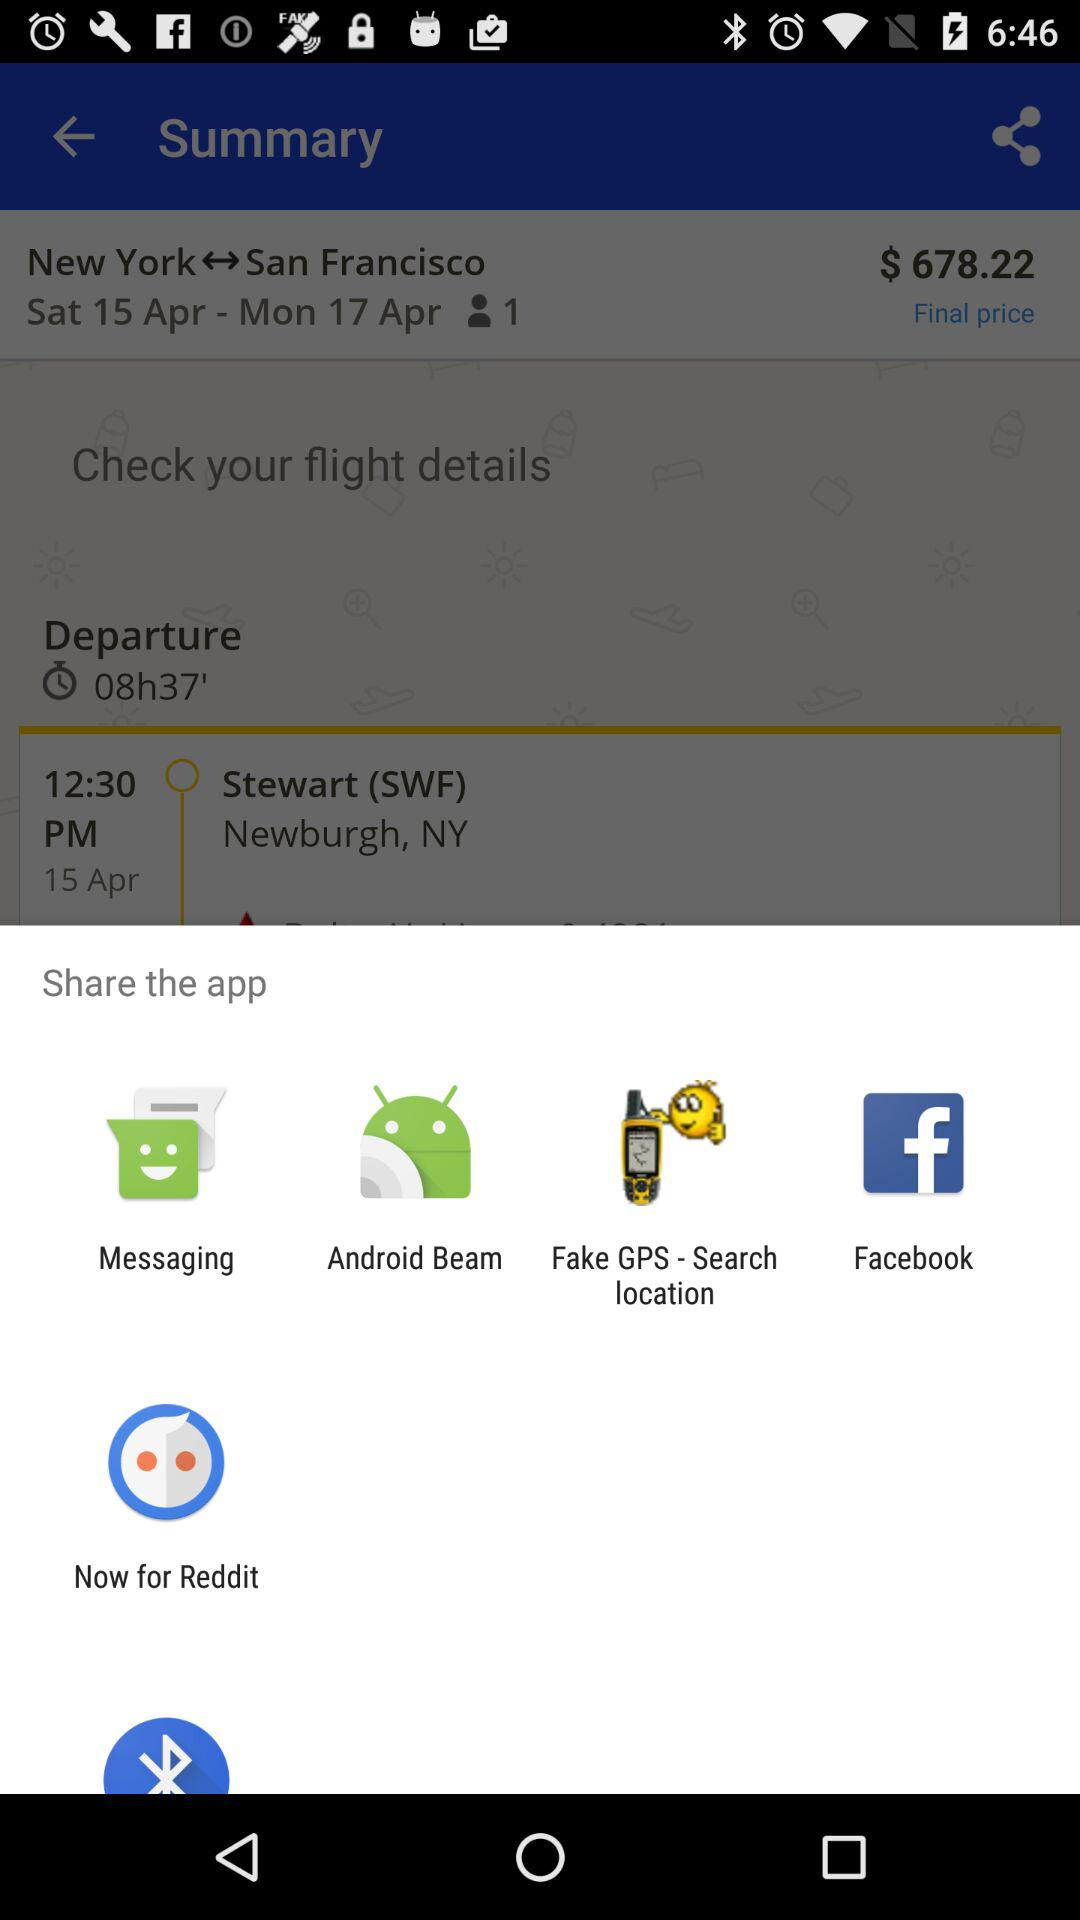What is the departure date of the flight? The departure date of the flight is Saturday, April 15. 